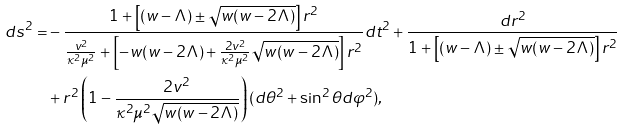Convert formula to latex. <formula><loc_0><loc_0><loc_500><loc_500>d s ^ { 2 } = & - \frac { 1 + \left [ ( w - \Lambda ) \pm \sqrt { w ( w - 2 \Lambda ) } \right ] r ^ { 2 } } { \frac { v ^ { 2 } } { \kappa ^ { 2 } \mu ^ { 2 } } + \left [ - w ( w - 2 \Lambda ) + \frac { 2 v ^ { 2 } } { \kappa ^ { 2 } \mu ^ { 2 } } \sqrt { w ( w - 2 \Lambda ) } \right ] r ^ { 2 } } d t ^ { 2 } + \frac { d r ^ { 2 } } { 1 + \left [ ( w - \Lambda ) \pm \sqrt { w ( w - 2 \Lambda ) } \right ] r ^ { 2 } } \\ & + r ^ { 2 } \left ( 1 - \frac { 2 v ^ { 2 } } { \kappa ^ { 2 } \mu ^ { 2 } \sqrt { w ( w - 2 \Lambda ) } } \right ) ( d \theta ^ { 2 } + \sin ^ { 2 } \theta d \varphi ^ { 2 } ) ,</formula> 